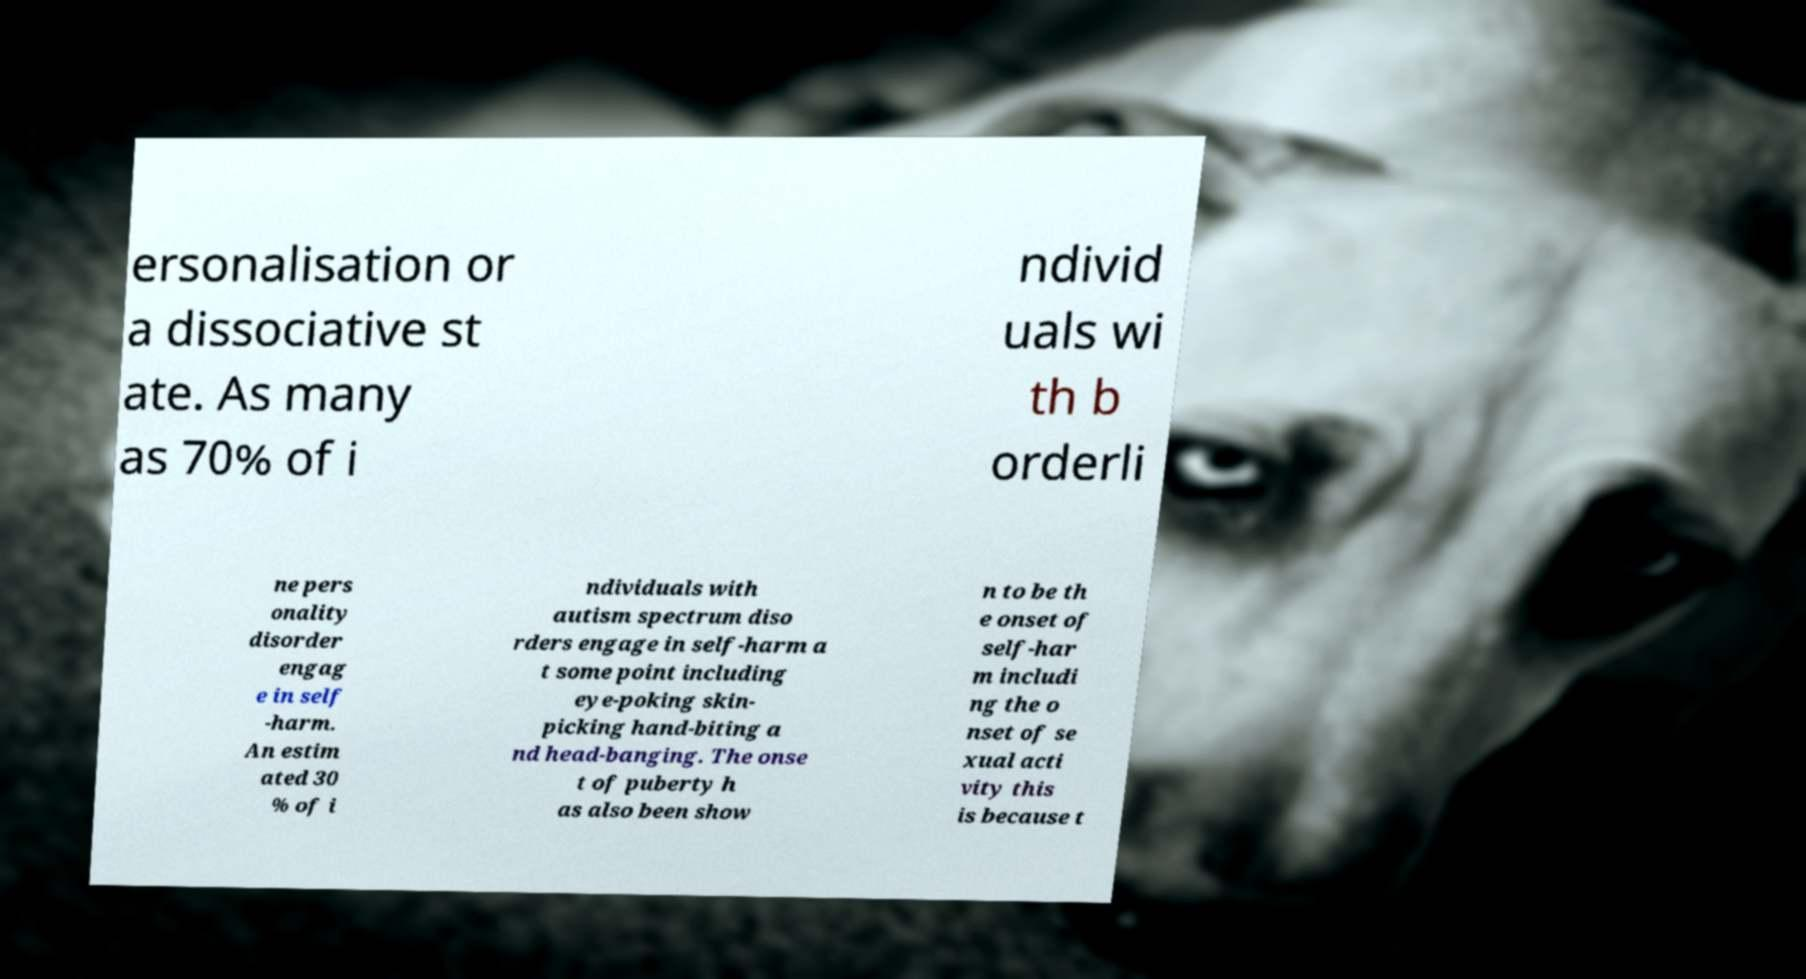For documentation purposes, I need the text within this image transcribed. Could you provide that? ersonalisation or a dissociative st ate. As many as 70% of i ndivid uals wi th b orderli ne pers onality disorder engag e in self -harm. An estim ated 30 % of i ndividuals with autism spectrum diso rders engage in self-harm a t some point including eye-poking skin- picking hand-biting a nd head-banging. The onse t of puberty h as also been show n to be th e onset of self-har m includi ng the o nset of se xual acti vity this is because t 